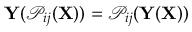Convert formula to latex. <formula><loc_0><loc_0><loc_500><loc_500>Y ( \mathcal { P } _ { i j } ( X ) ) = \mathcal { P } _ { i j } ( Y ( \mathbf { X } ) )</formula> 